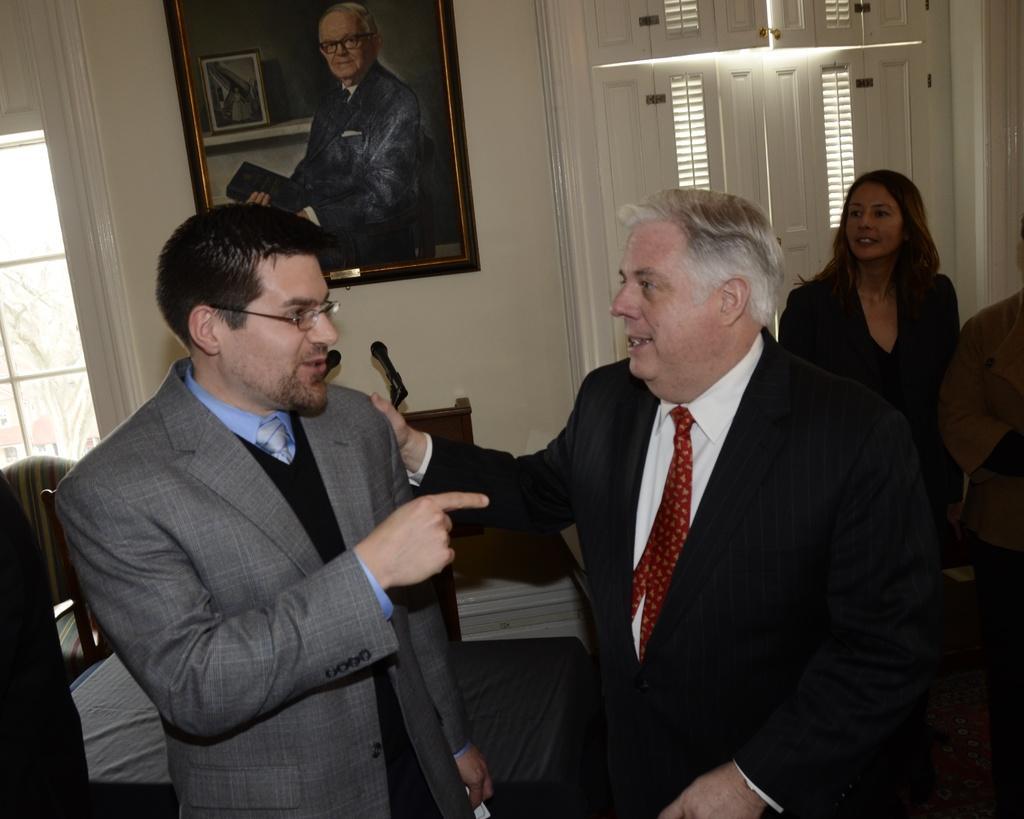Can you describe this image briefly? This is the picture of a room. In the foreground there are two persons standing and talking. At the back there are two persons standing. At the back there are microphones on the table and there are windows. There is a frame on the wall, on the frame there is a picture of a person. There is a tree behind the window. 